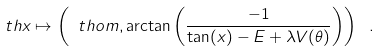<formula> <loc_0><loc_0><loc_500><loc_500>\ t h x \mapsto \left ( \ t h o m , \arctan \left ( \frac { - 1 } { \tan ( x ) - E + \lambda V ( \theta ) } \right ) \right ) \ .</formula> 